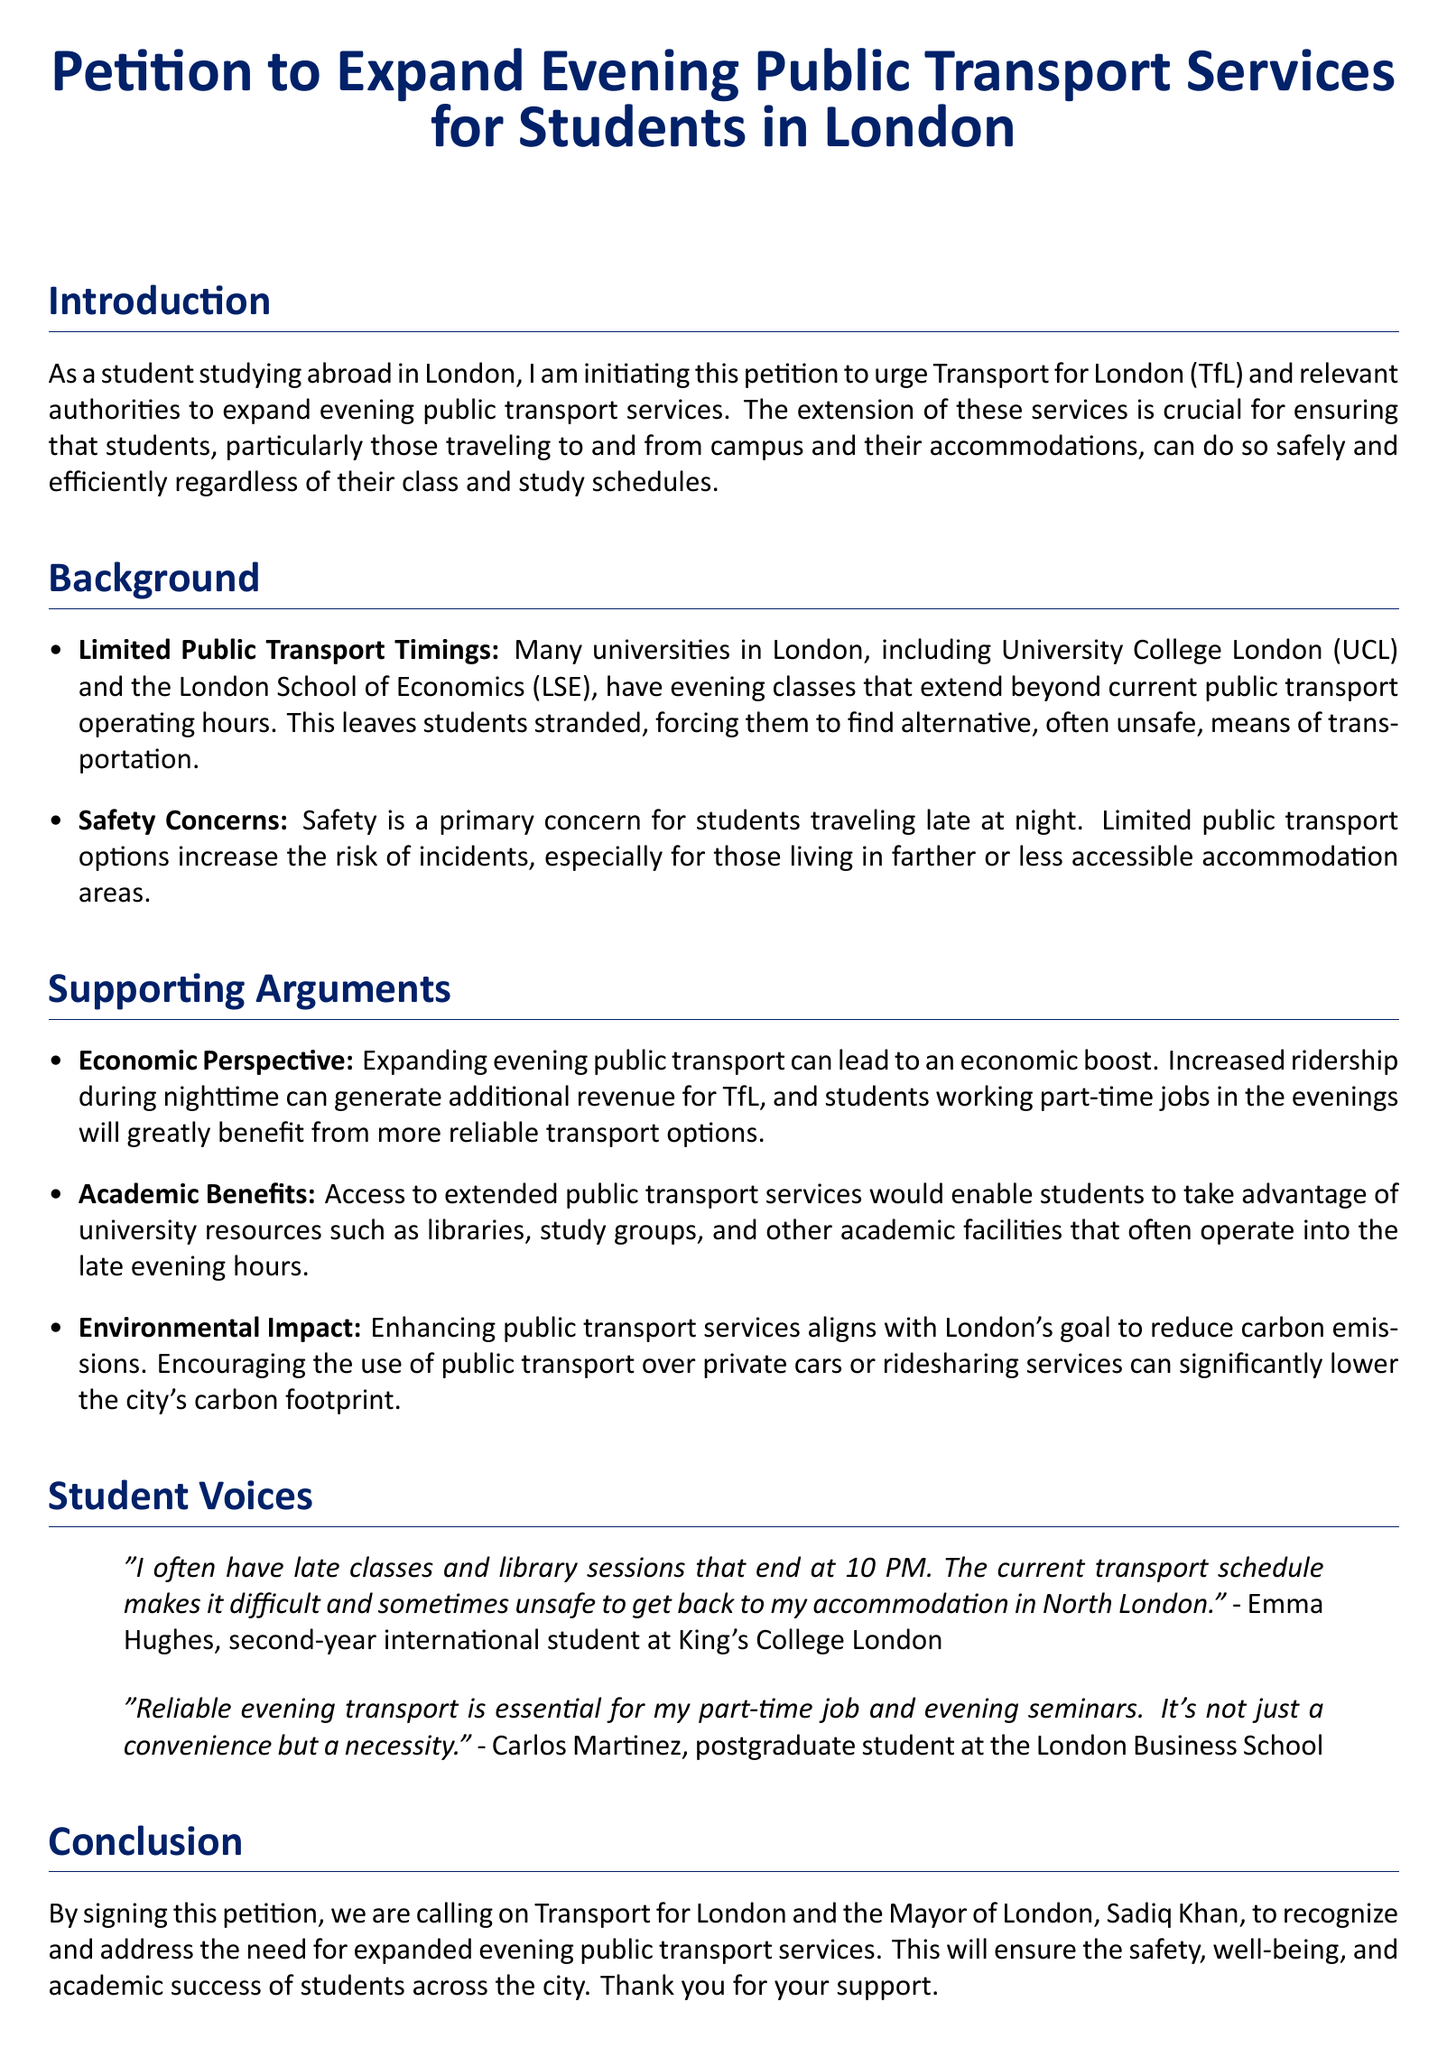What is the title of the petition? The title is prominently stated at the beginning of the document, which is indicative of its purpose.
Answer: Petition to Expand Evening Public Transport Services for Students in London Who initiated the petition? The document states that a student studying abroad in London is taking the initiative for this petition.
Answer: A student studying abroad in London Which transport authority is being addressed? The document identifies Transport for London (TfL) as the relevant authority to address for the expansion of services.
Answer: Transport for London (TfL) What is one supporting argument mentioned for expanding transport services? The document lists several supporting arguments; one specific benefit is highlighted in the text.
Answer: Economic Perspective Who is quoted in the document regarding late classes? The document includes student voices, highlighting their concerns about late classes and transport.
Answer: Emma Hughes What is the date format expected for signatures? The petition includes a section for signatures where the date is intended to be filled out.
Answer: Date What color is used for the section titles? The document specifies a color scheme used for different parts of the text, particularly in headings.
Answer: British blue What is the call to action in the petition? The end of the document features a statement urging readers to take specific action regarding the petition.
Answer: Please sign this petition How does the petition address safety concerns? The document details safety as a primary concern related to public transport and student travel, explaining why more services are needed.
Answer: Safety Concerns 